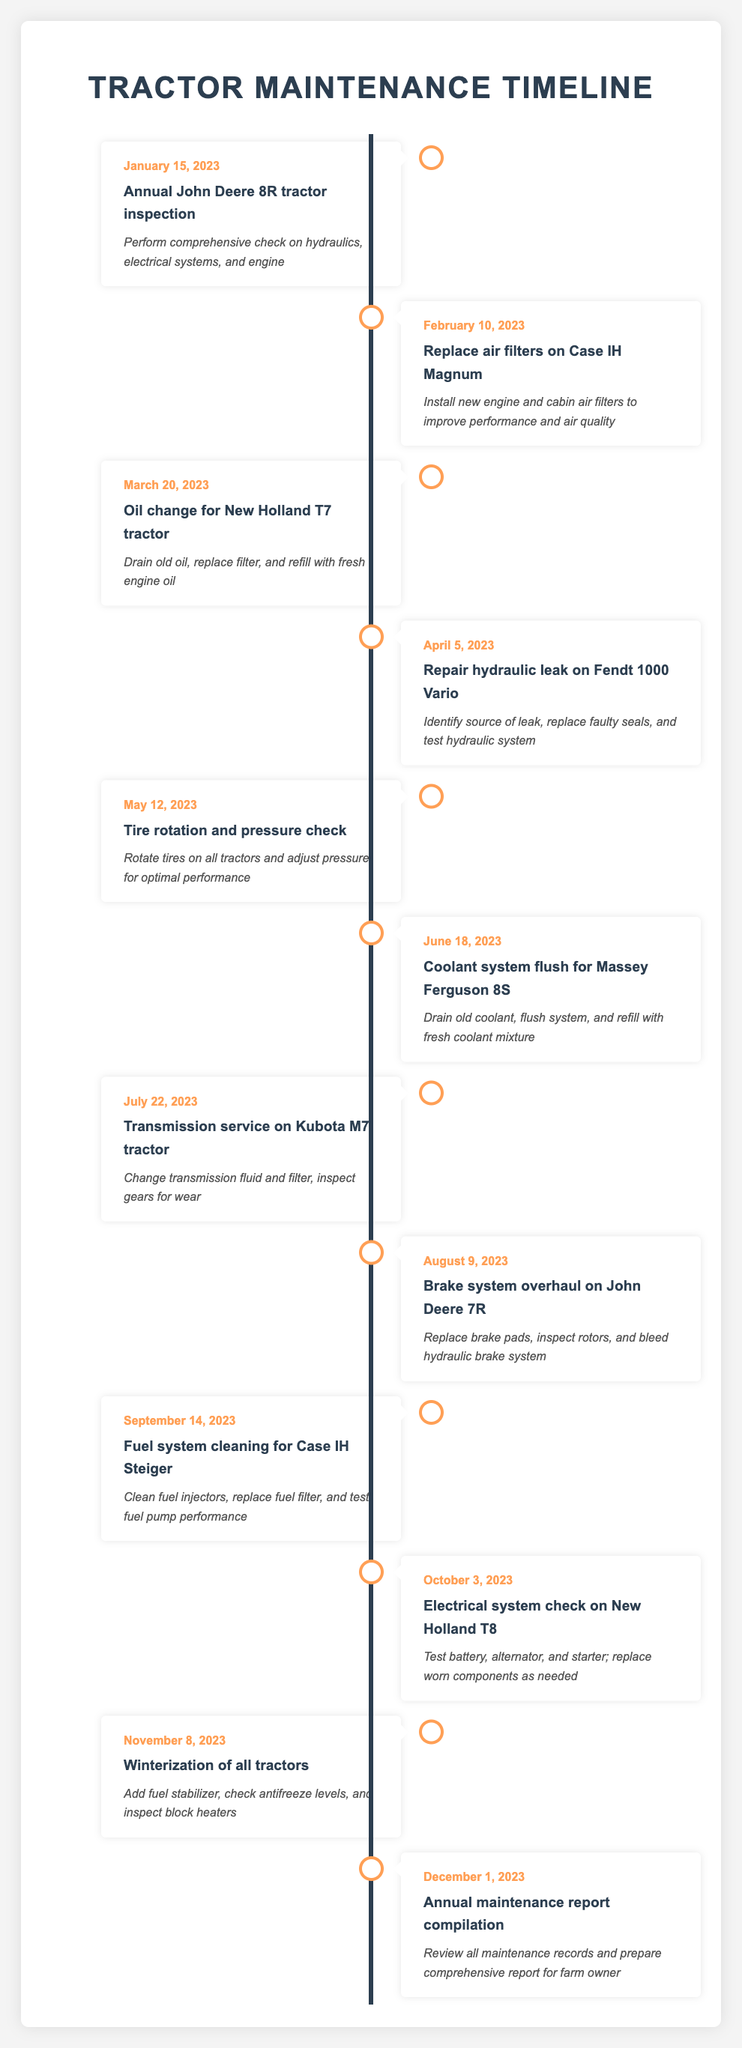What is the first maintenance task scheduled for 2023? The first maintenance task listed in the timeline is the "Annual John Deere 8R tractor inspection," scheduled for January 15, 2023.
Answer: Annual John Deere 8R tractor inspection How many maintenance tasks are planned from April to June? The maintenance tasks scheduled between April and June are as follows: 1) Repair hydraulic leak on Fendt 1000 Vario (April 5), 2) Tire rotation and pressure check (May 12), and 3) Coolant system flush for Massey Ferguson 8S (June 18). This totals to three tasks.
Answer: 3 Is there a brake system overhaul scheduled for the year? Yes, there is a brake system overhaul scheduled for the John Deere 7R on August 9, 2023.
Answer: Yes What tasks are scheduled for the second half of the year? The tasks scheduled from July to December are: 1) Transmission service on Kubota M7 (July 22), 2) Brake system overhaul on John Deere 7R (August 9), 3) Fuel system cleaning for Case IH Steiger (September 14), 4) Electrical system check on New Holland T8 (October 3), 5) Winterization of all tractors (November 8), and 6) Annual maintenance report compilation (December 1). This totals six tasks.
Answer: 6 What is the average time gap between the scheduled maintenance tasks? To calculate the average time gap, we first need to find the number of days between each task's date, which totals to 326 days. There are 11 tasks, meaning there are 10 gaps to divide. Thus, the average time gap is 326 days / 10 = 32.6 days.
Answer: 32.6 days How many tasks involve checking or replacing fluids? The tasks involving checking or replacing fluids are: 1) Oil change for New Holland T7 (March 20), 2) Coolant system flush for Massey Ferguson 8S (June 18), 3) Transmission service on Kubota M7 (July 22), and 4) Fuel system cleaning for Case IH Steiger (September 14). This totals four tasks.
Answer: 4 Is there any task related to winterization? Yes, there is a winterization task scheduled for November 8, 2023, which involves adding fuel stabilizer, checking antifreeze levels, and inspecting block heaters.
Answer: Yes What is the last scheduled maintenance task of the year? The last scheduled maintenance task listed is the "Annual maintenance report compilation," taking place on December 1, 2023.
Answer: Annual maintenance report compilation 